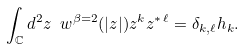Convert formula to latex. <formula><loc_0><loc_0><loc_500><loc_500>\int _ { \mathbb { C } } d ^ { 2 } z \ w ^ { \beta = 2 } ( | z | ) z ^ { k } z ^ { * \, \ell } = \delta _ { k , \ell } h _ { k } .</formula> 